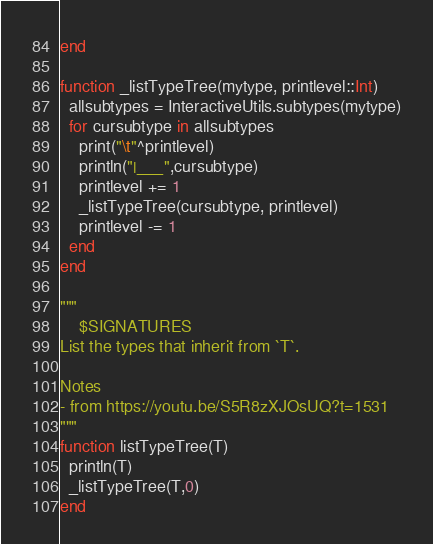<code> <loc_0><loc_0><loc_500><loc_500><_Julia_>end

function _listTypeTree(mytype, printlevel::Int)
  allsubtypes = InteractiveUtils.subtypes(mytype)
  for cursubtype in allsubtypes
    print("\t"^printlevel)
    println("|___",cursubtype)
    printlevel += 1
    _listTypeTree(cursubtype, printlevel)
    printlevel -= 1
  end
end

"""
    $SIGNATURES
List the types that inherit from `T`.

Notes
- from https://youtu.be/S5R8zXJOsUQ?t=1531
"""
function listTypeTree(T)
  println(T)
  _listTypeTree(T,0)
end
</code> 